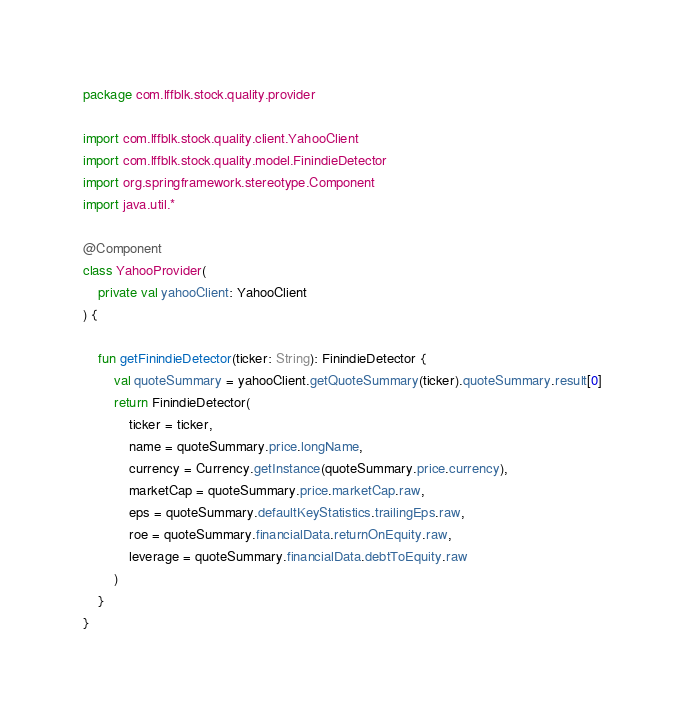<code> <loc_0><loc_0><loc_500><loc_500><_Kotlin_>package com.lffblk.stock.quality.provider

import com.lffblk.stock.quality.client.YahooClient
import com.lffblk.stock.quality.model.FinindieDetector
import org.springframework.stereotype.Component
import java.util.*

@Component
class YahooProvider(
    private val yahooClient: YahooClient
) {

    fun getFinindieDetector(ticker: String): FinindieDetector {
        val quoteSummary = yahooClient.getQuoteSummary(ticker).quoteSummary.result[0]
        return FinindieDetector(
            ticker = ticker,
            name = quoteSummary.price.longName,
            currency = Currency.getInstance(quoteSummary.price.currency),
            marketCap = quoteSummary.price.marketCap.raw,
            eps = quoteSummary.defaultKeyStatistics.trailingEps.raw,
            roe = quoteSummary.financialData.returnOnEquity.raw,
            leverage = quoteSummary.financialData.debtToEquity.raw
        )
    }
}</code> 